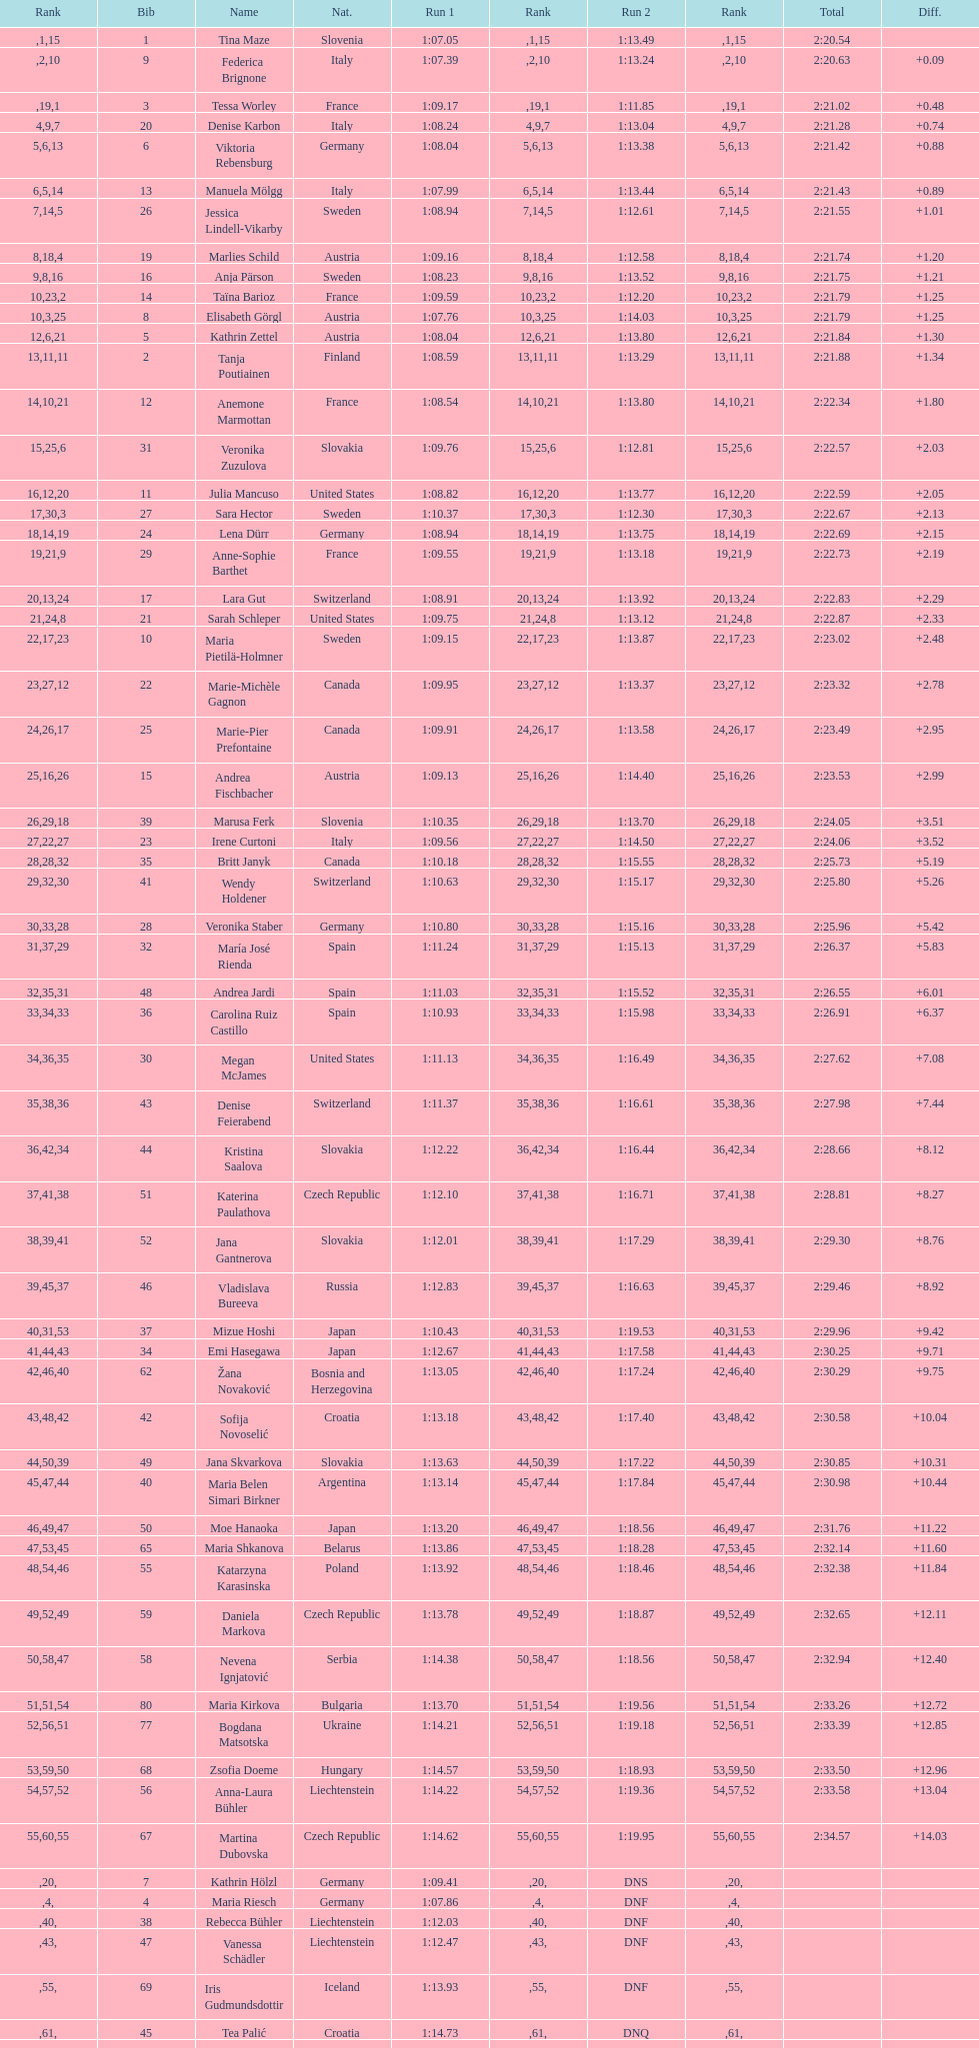What was the number of swedes in the top fifteen? 2. 